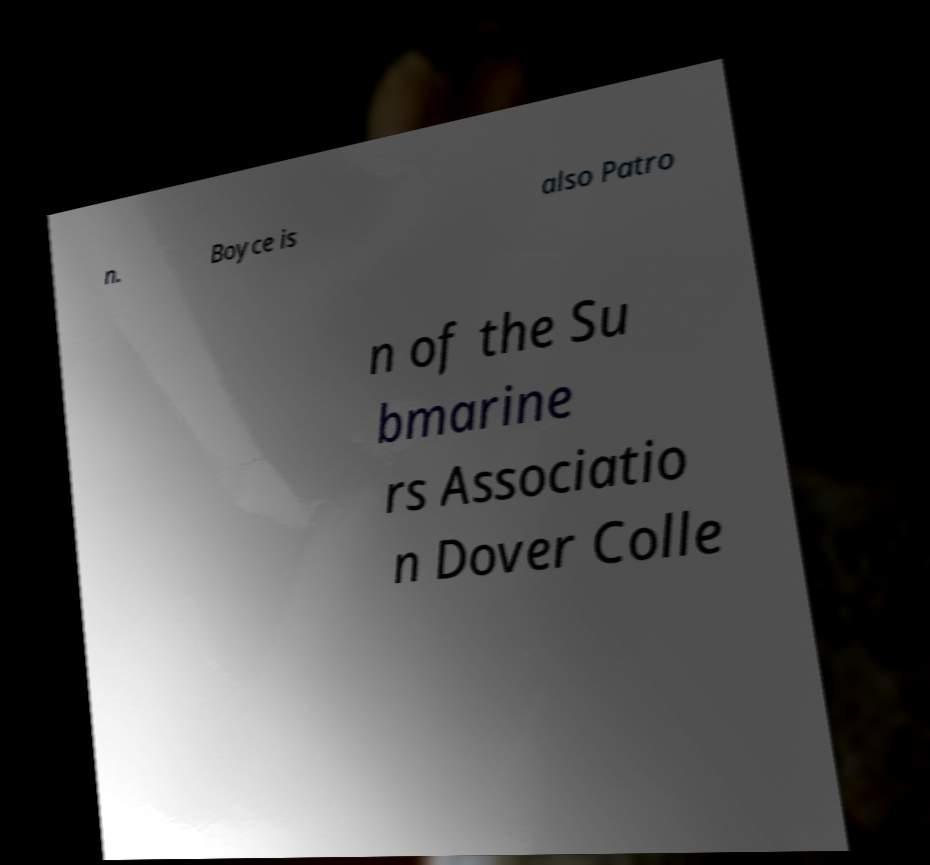I need the written content from this picture converted into text. Can you do that? n. Boyce is also Patro n of the Su bmarine rs Associatio n Dover Colle 